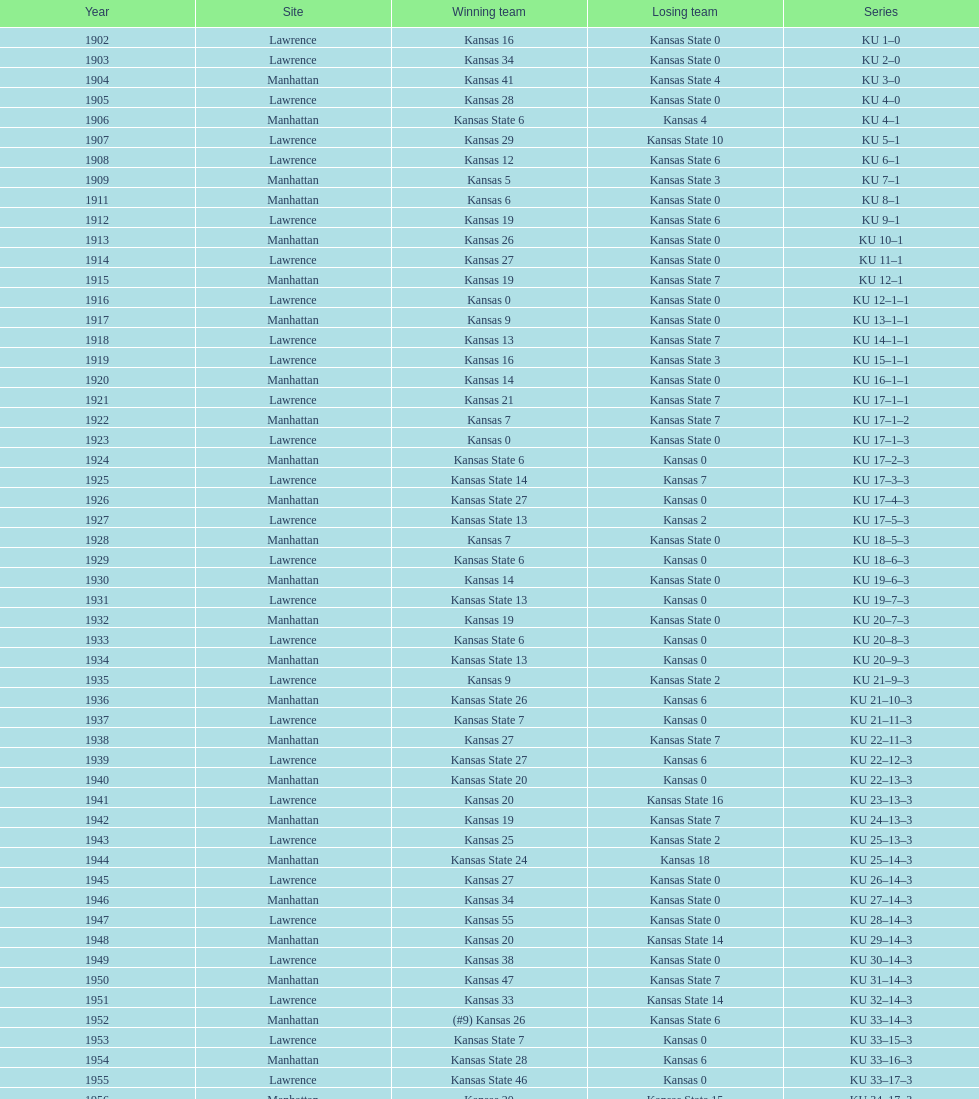How many times did kansas and kansas state play in lawrence from 1902-1968? 34. 